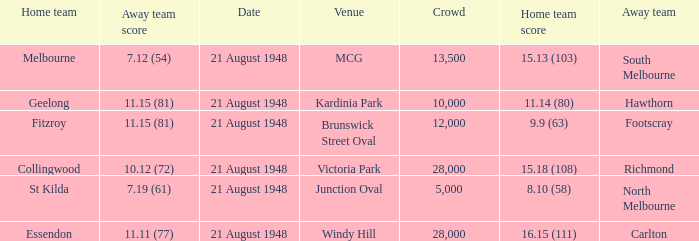When the Home team score was 15.18 (108), what's the lowest Crowd turnout? 28000.0. 